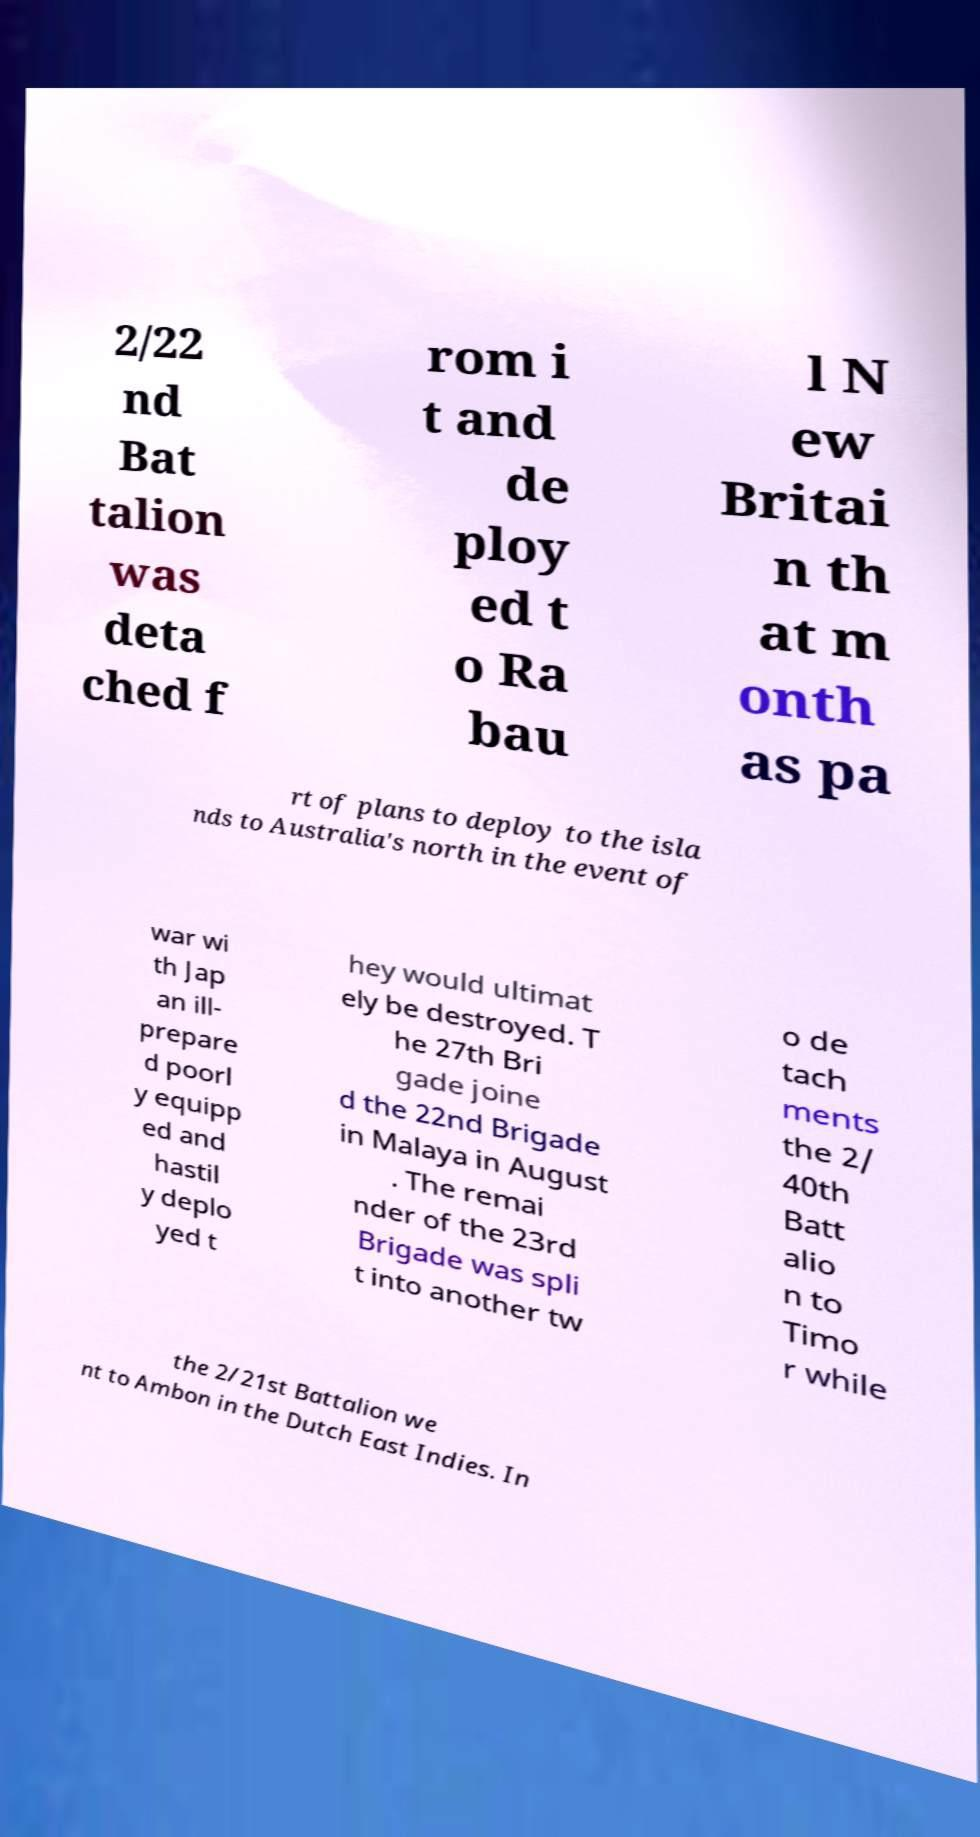I need the written content from this picture converted into text. Can you do that? 2/22 nd Bat talion was deta ched f rom i t and de ploy ed t o Ra bau l N ew Britai n th at m onth as pa rt of plans to deploy to the isla nds to Australia's north in the event of war wi th Jap an ill- prepare d poorl y equipp ed and hastil y deplo yed t hey would ultimat ely be destroyed. T he 27th Bri gade joine d the 22nd Brigade in Malaya in August . The remai nder of the 23rd Brigade was spli t into another tw o de tach ments the 2/ 40th Batt alio n to Timo r while the 2/21st Battalion we nt to Ambon in the Dutch East Indies. In 